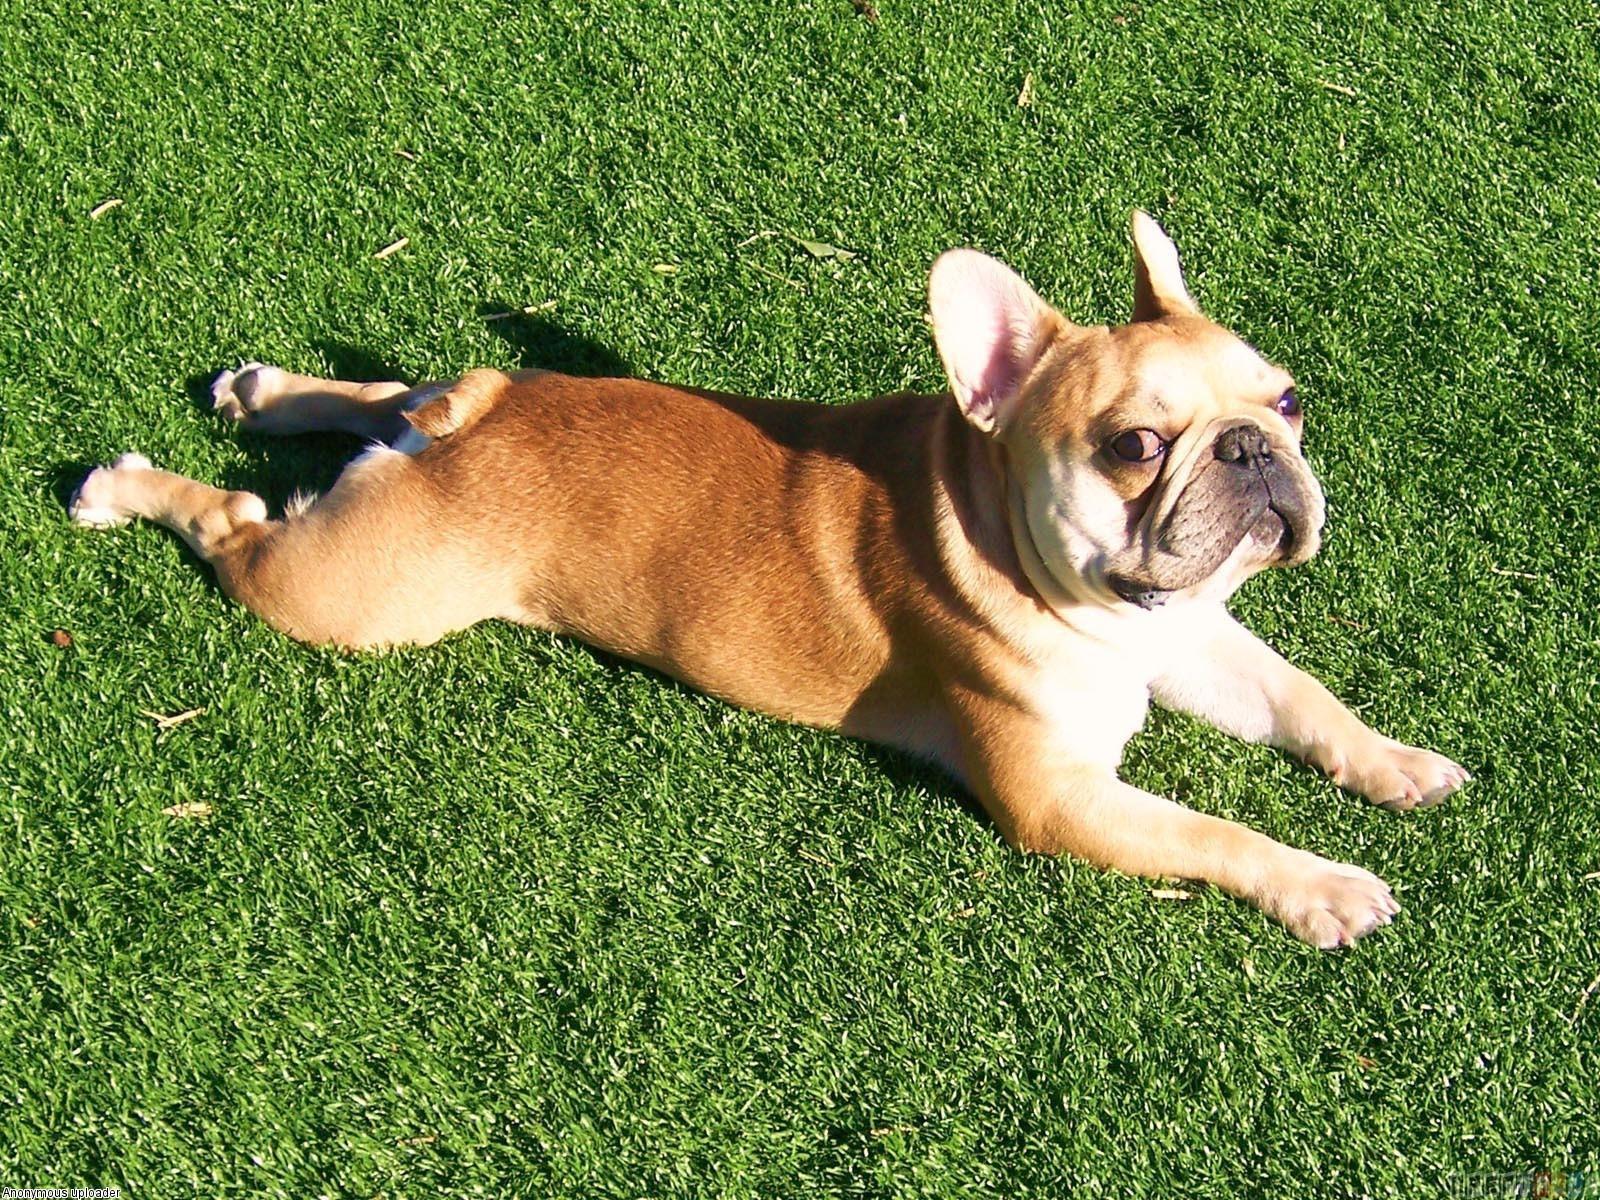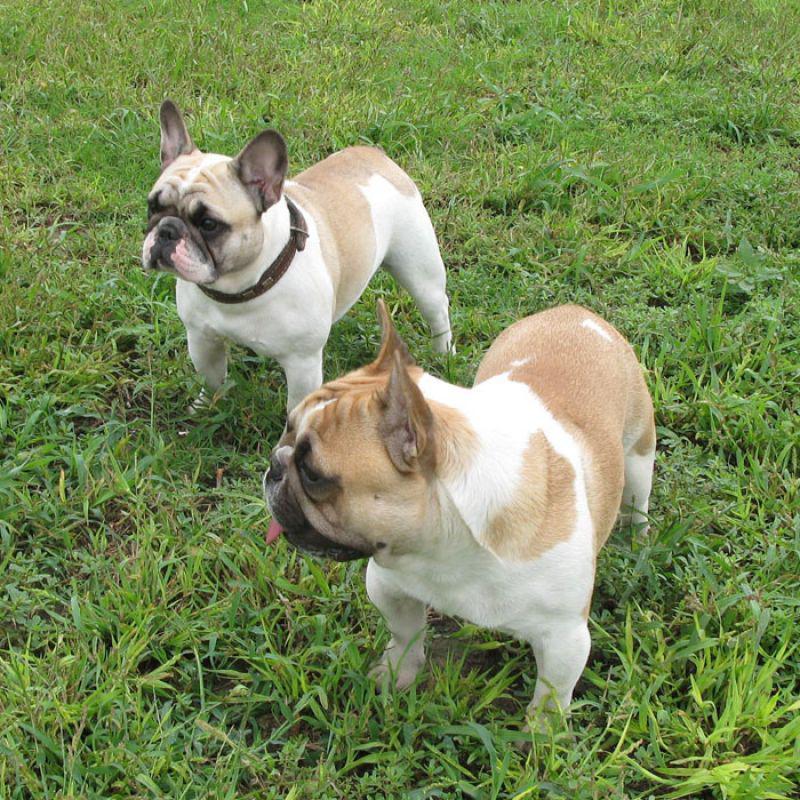The first image is the image on the left, the second image is the image on the right. Given the left and right images, does the statement "One of the images shows a bulldog on a leash with its body facing leftward." hold true? Answer yes or no. No. The first image is the image on the left, the second image is the image on the right. For the images displayed, is the sentence "There are two dogs in the right image." factually correct? Answer yes or no. Yes. 